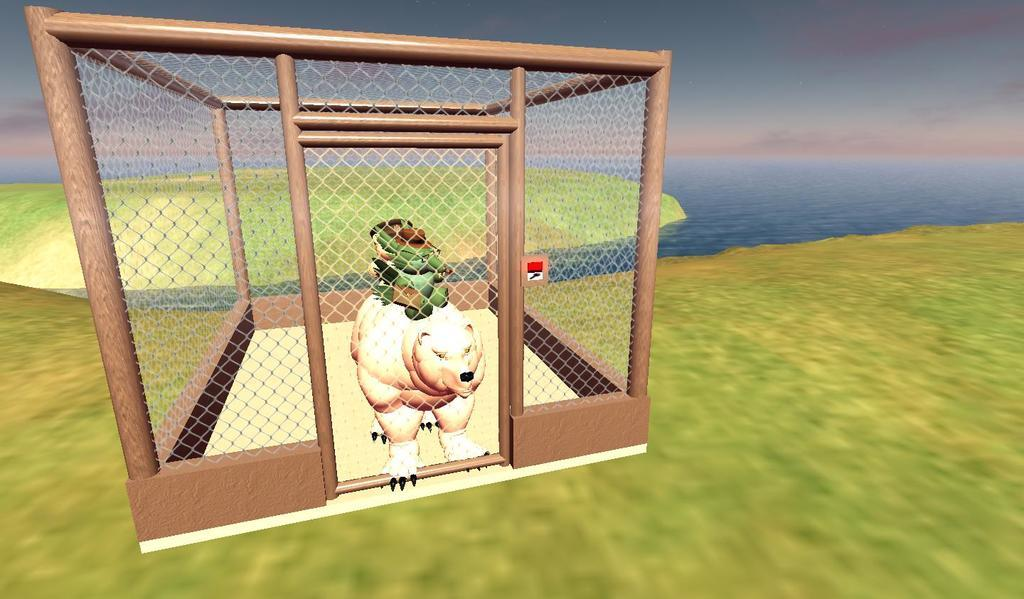What type of animals can be seen inside the den? There are animals inside the den, but the specific type is not mentioned in the facts. What can be seen in the background of the scene? Water, ground, and the sky are visible in the background of the scene. How many elements can be seen in the background? Three elements can be seen in the background: water, ground, and the sky. What type of cloth is draped over the animals in the den? There is no mention of cloth in the image, so it cannot be determined if any cloth is draped over the animals. How many ducks are swimming in the water in the background? There is no mention of ducks in the image, so it cannot be determined if any ducks are present. 